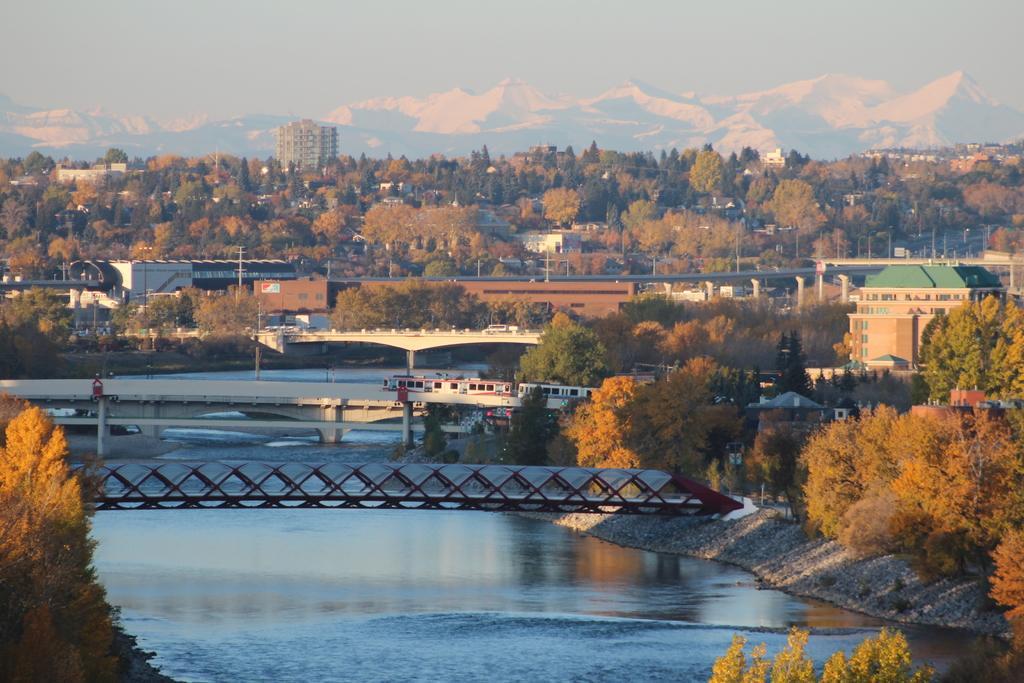Could you give a brief overview of what you see in this image? In this image, we can see bridges and there are trees, buildings, poles, vehicles on the road, mountains and boards. At the bottom, there is water and at the top, there is sky. 